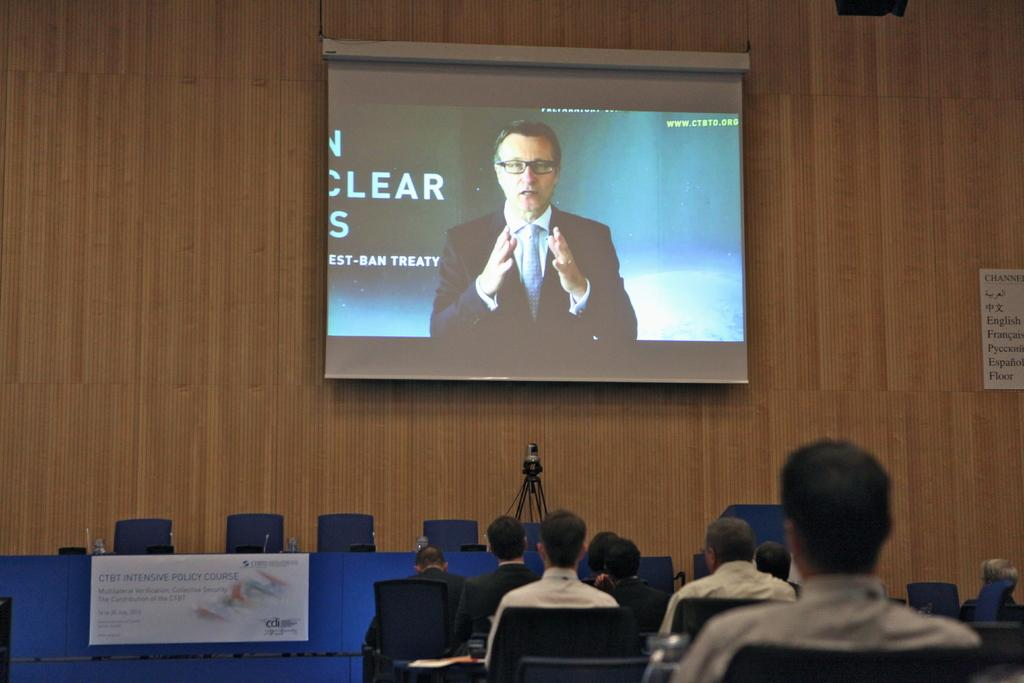How many people are in the image? There is a group of people in the image. What are the people doing in the image? The people are sitting on chairs. What objects are related to audio in the image? There are microphone stands in the image. What objects are related to video in the image? There is a camera on a tripod stand. What objects are related to refreshments in the image? There are glasses on a table. What objects are related to presentations in the image? There is a board and a screen attached to a wall. What word is written on the stick in the image? There is no stick or word present in the image. 